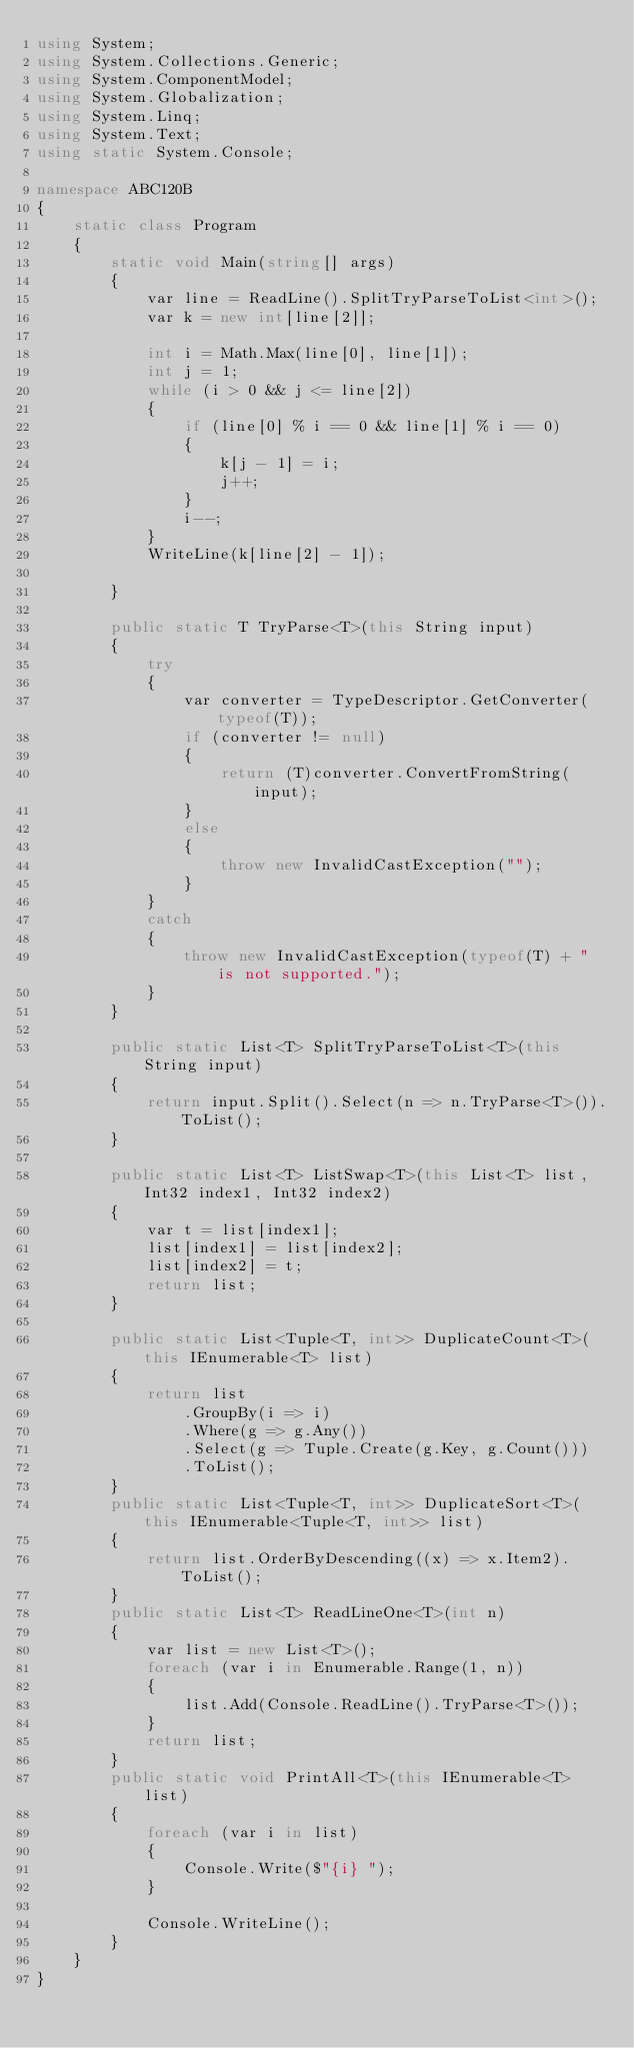<code> <loc_0><loc_0><loc_500><loc_500><_C#_>using System;
using System.Collections.Generic;
using System.ComponentModel;
using System.Globalization;
using System.Linq;
using System.Text;
using static System.Console;

namespace ABC120B
{
    static class Program
    {
        static void Main(string[] args)
        {
            var line = ReadLine().SplitTryParseToList<int>();
            var k = new int[line[2]];

            int i = Math.Max(line[0], line[1]);
            int j = 1;
            while (i > 0 && j <= line[2])
            {
                if (line[0] % i == 0 && line[1] % i == 0)
                {
                    k[j - 1] = i;
                    j++;
                }
                i--;
            }
            WriteLine(k[line[2] - 1]);

        }

        public static T TryParse<T>(this String input)
        {
            try
            {
                var converter = TypeDescriptor.GetConverter(typeof(T));
                if (converter != null)
                {
                    return (T)converter.ConvertFromString(input);
                }
                else
                {
                    throw new InvalidCastException("");
                }
            }
            catch
            {
                throw new InvalidCastException(typeof(T) + " is not supported.");
            }
        }

        public static List<T> SplitTryParseToList<T>(this String input)
        {
            return input.Split().Select(n => n.TryParse<T>()).ToList();
        }

        public static List<T> ListSwap<T>(this List<T> list, Int32 index1, Int32 index2)
        {
            var t = list[index1];
            list[index1] = list[index2];
            list[index2] = t;
            return list;
        }

        public static List<Tuple<T, int>> DuplicateCount<T>(this IEnumerable<T> list)
        {
            return list
                .GroupBy(i => i)
                .Where(g => g.Any())
                .Select(g => Tuple.Create(g.Key, g.Count()))
                .ToList();
        }
        public static List<Tuple<T, int>> DuplicateSort<T>(this IEnumerable<Tuple<T, int>> list)
        {
            return list.OrderByDescending((x) => x.Item2).ToList();
        }
        public static List<T> ReadLineOne<T>(int n)
        {
            var list = new List<T>();
            foreach (var i in Enumerable.Range(1, n))
            {
                list.Add(Console.ReadLine().TryParse<T>());
            }
            return list;
        }
        public static void PrintAll<T>(this IEnumerable<T> list)
        {
            foreach (var i in list)
            {
                Console.Write($"{i} ");
            }

            Console.WriteLine();
        }
    }
}
</code> 